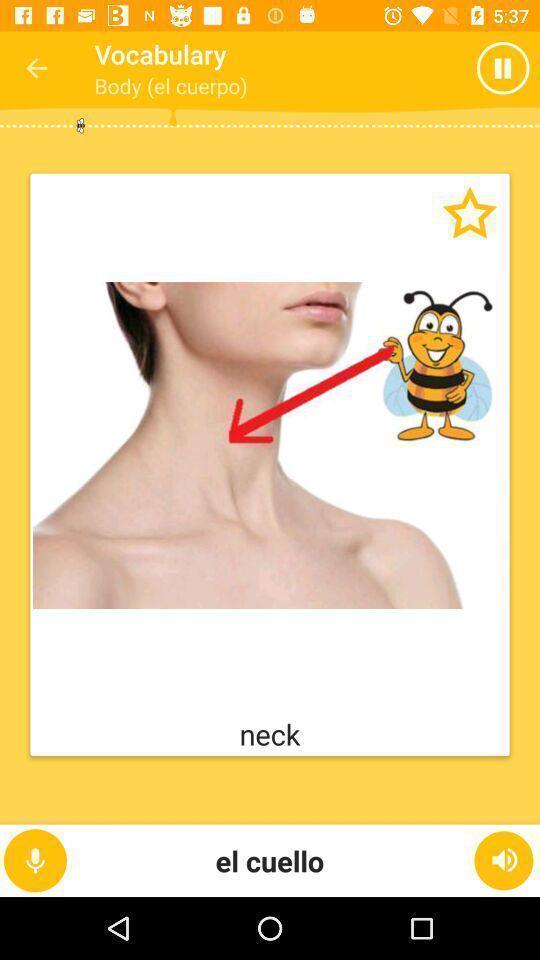Provide a detailed account of this screenshot. Vocabulary page of a language learning app. 